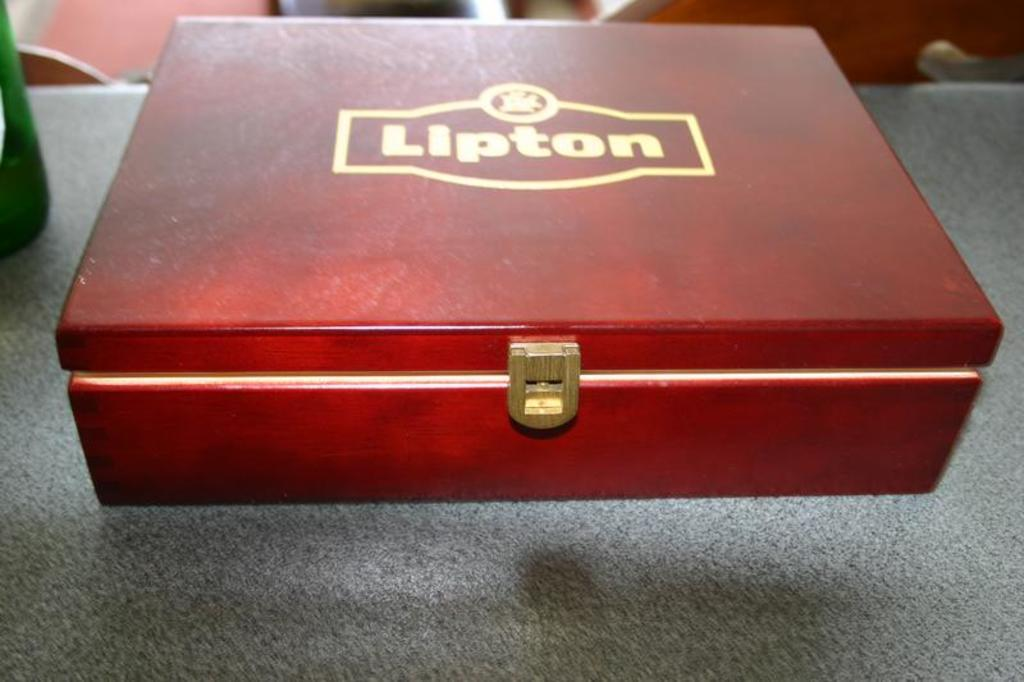<image>
Create a compact narrative representing the image presented. The Lipton logo is on the outside of red box. 